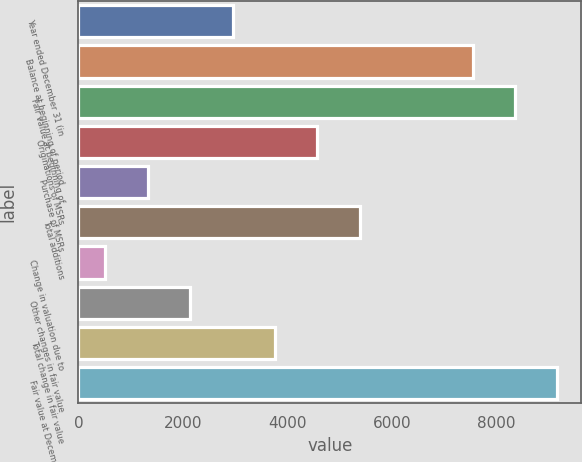Convert chart. <chart><loc_0><loc_0><loc_500><loc_500><bar_chart><fcel>Year ended December 31 (in<fcel>Balance at beginning of period<fcel>Fair value at beginning of<fcel>Originations of MSRs<fcel>Purchase of MSRs<fcel>Total additions<fcel>Change in valuation due to<fcel>Other changes in fair value<fcel>Total change in fair value<fcel>Fair value at December 31<nl><fcel>2950.8<fcel>7546<fcel>8357.6<fcel>4574<fcel>1327.6<fcel>5385.6<fcel>516<fcel>2139.2<fcel>3762.4<fcel>9169.2<nl></chart> 